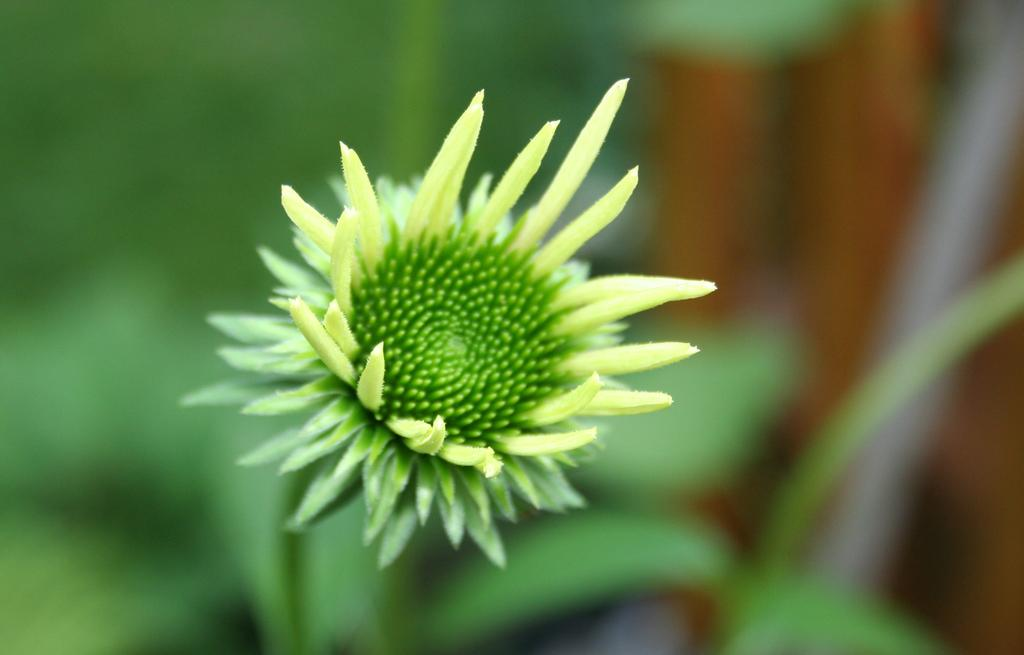What is the main subject of the image? There is a flower in the image. What color is the flower? The flower is green in color. Can you describe the background of the image? The background of the image is blurred. Can you hear the flower laughing in the image? There is no sound or laughter present in the image, as it is a still photograph of a flower. 